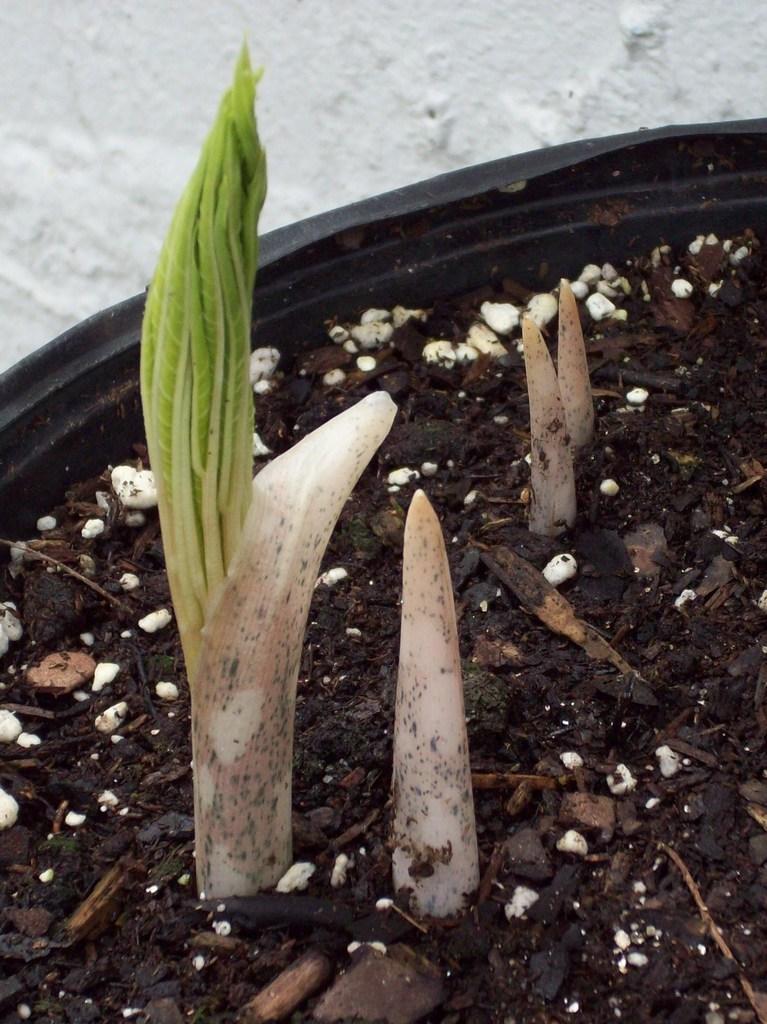How would you summarize this image in a sentence or two? In this picture we can see a houseplant and in the background we can see the ground. 